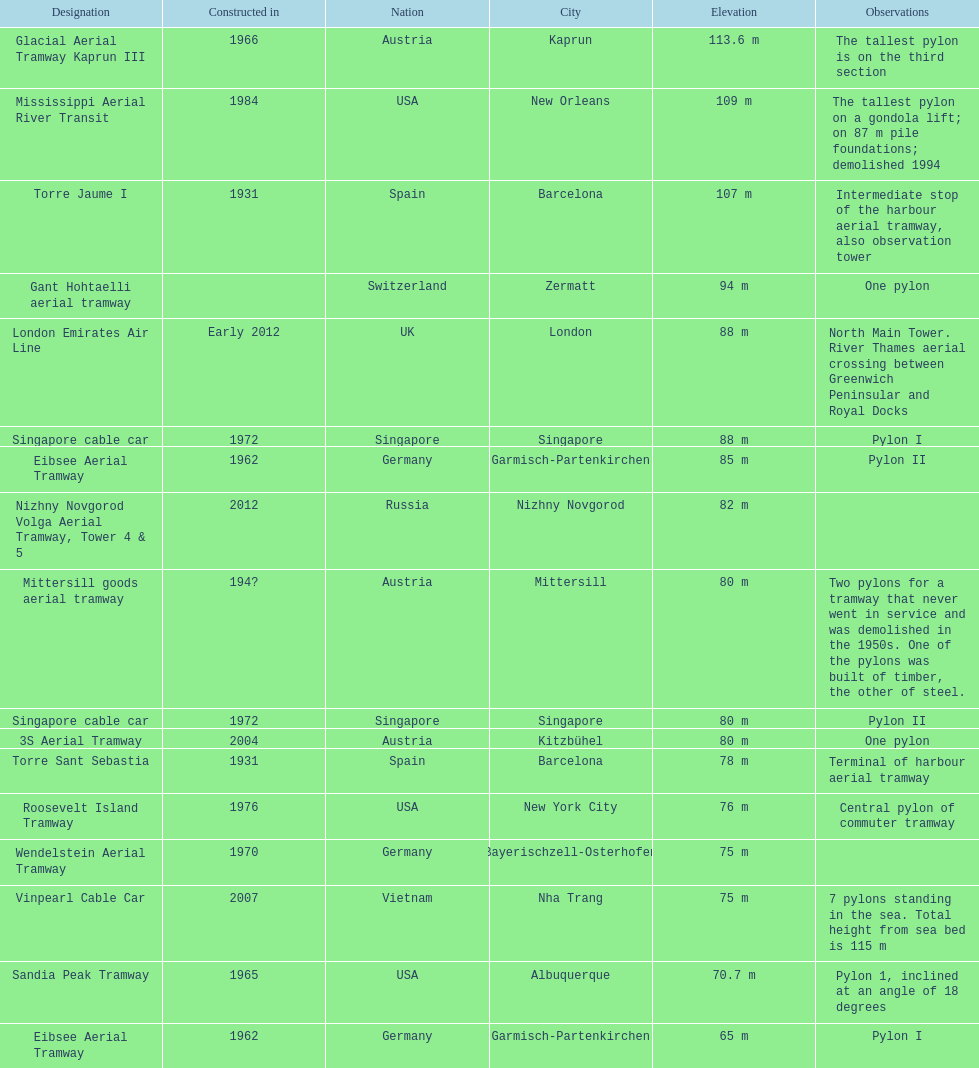How many metres is the mississippi aerial river transit from bottom to top? 109 m. 